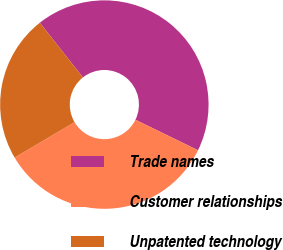Convert chart. <chart><loc_0><loc_0><loc_500><loc_500><pie_chart><fcel>Trade names<fcel>Customer relationships<fcel>Unpatented technology<nl><fcel>42.86%<fcel>34.29%<fcel>22.86%<nl></chart> 